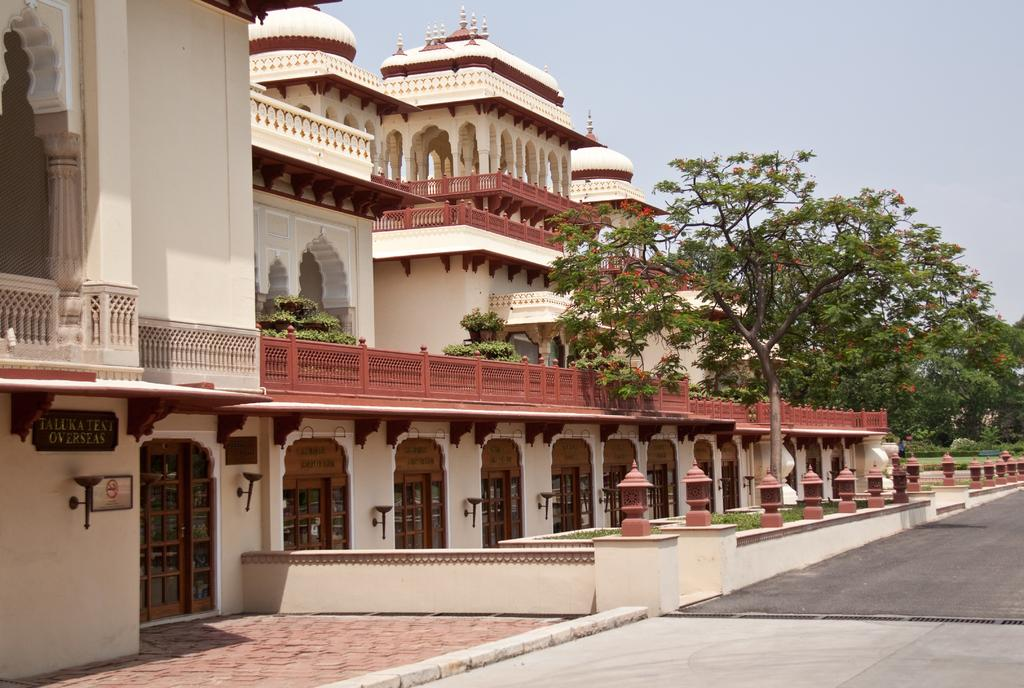What can be seen in the center of the image? There are buildings and trees in the center of the image. What is located at the bottom of the image? There is a road at the bottom of the image. What is visible in the background of the image? The sky is visible in the background of the image. Where is the spade located in the image? There is no spade present in the image. What type of transportation is available at the airport in the image? There is no airport present in the image. 